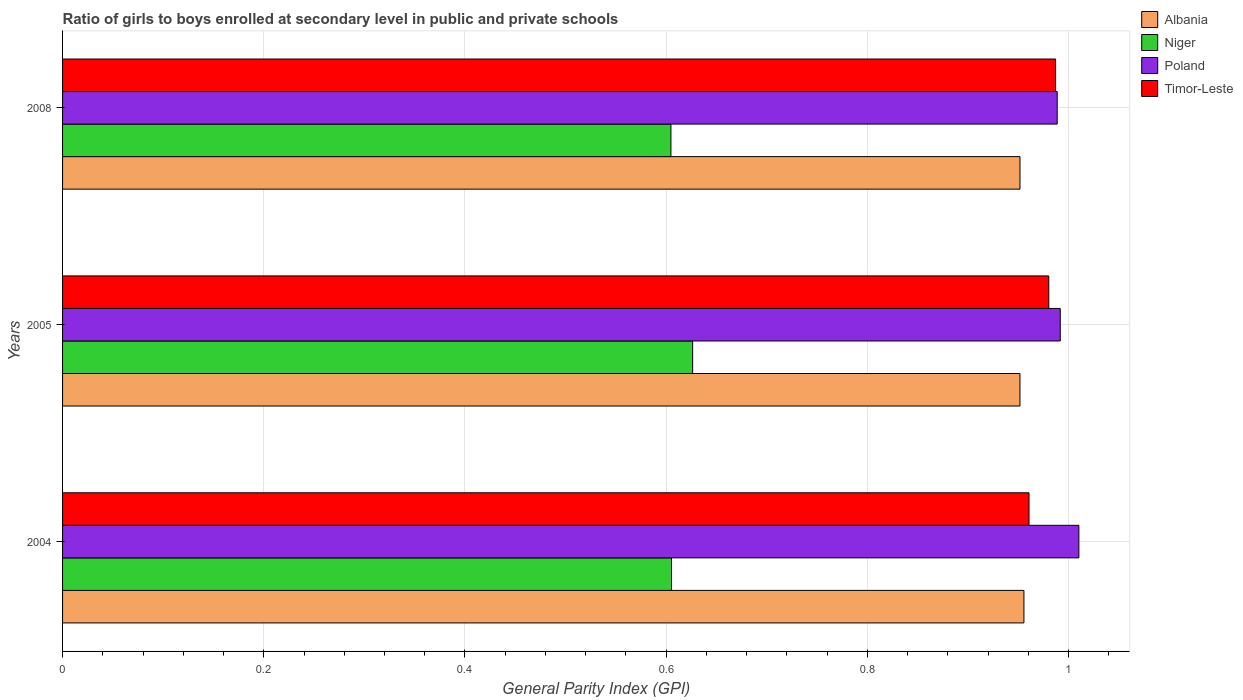How many different coloured bars are there?
Make the answer very short. 4. How many bars are there on the 1st tick from the top?
Give a very brief answer. 4. What is the label of the 2nd group of bars from the top?
Provide a short and direct response. 2005. In how many cases, is the number of bars for a given year not equal to the number of legend labels?
Provide a short and direct response. 0. What is the general parity index in Timor-Leste in 2008?
Keep it short and to the point. 0.99. Across all years, what is the maximum general parity index in Poland?
Your answer should be compact. 1.01. Across all years, what is the minimum general parity index in Poland?
Your response must be concise. 0.99. What is the total general parity index in Poland in the graph?
Make the answer very short. 2.99. What is the difference between the general parity index in Poland in 2005 and that in 2008?
Keep it short and to the point. 0. What is the difference between the general parity index in Niger in 2004 and the general parity index in Poland in 2005?
Provide a short and direct response. -0.39. What is the average general parity index in Timor-Leste per year?
Your answer should be compact. 0.98. In the year 2005, what is the difference between the general parity index in Timor-Leste and general parity index in Niger?
Your answer should be very brief. 0.35. In how many years, is the general parity index in Timor-Leste greater than 0.52 ?
Offer a terse response. 3. What is the ratio of the general parity index in Niger in 2005 to that in 2008?
Provide a short and direct response. 1.04. What is the difference between the highest and the second highest general parity index in Albania?
Provide a short and direct response. 0. What is the difference between the highest and the lowest general parity index in Albania?
Ensure brevity in your answer.  0. Is it the case that in every year, the sum of the general parity index in Timor-Leste and general parity index in Albania is greater than the sum of general parity index in Poland and general parity index in Niger?
Keep it short and to the point. Yes. What does the 3rd bar from the top in 2005 represents?
Provide a short and direct response. Niger. What does the 4th bar from the bottom in 2008 represents?
Provide a short and direct response. Timor-Leste. Are all the bars in the graph horizontal?
Offer a terse response. Yes. How many years are there in the graph?
Keep it short and to the point. 3. What is the difference between two consecutive major ticks on the X-axis?
Provide a succinct answer. 0.2. Are the values on the major ticks of X-axis written in scientific E-notation?
Keep it short and to the point. No. Does the graph contain any zero values?
Your response must be concise. No. How many legend labels are there?
Offer a terse response. 4. How are the legend labels stacked?
Your answer should be very brief. Vertical. What is the title of the graph?
Your response must be concise. Ratio of girls to boys enrolled at secondary level in public and private schools. What is the label or title of the X-axis?
Provide a short and direct response. General Parity Index (GPI). What is the label or title of the Y-axis?
Provide a succinct answer. Years. What is the General Parity Index (GPI) in Albania in 2004?
Your response must be concise. 0.96. What is the General Parity Index (GPI) of Niger in 2004?
Keep it short and to the point. 0.61. What is the General Parity Index (GPI) of Poland in 2004?
Your response must be concise. 1.01. What is the General Parity Index (GPI) in Timor-Leste in 2004?
Ensure brevity in your answer.  0.96. What is the General Parity Index (GPI) in Albania in 2005?
Ensure brevity in your answer.  0.95. What is the General Parity Index (GPI) of Niger in 2005?
Keep it short and to the point. 0.63. What is the General Parity Index (GPI) of Poland in 2005?
Ensure brevity in your answer.  0.99. What is the General Parity Index (GPI) of Timor-Leste in 2005?
Your answer should be compact. 0.98. What is the General Parity Index (GPI) of Albania in 2008?
Provide a succinct answer. 0.95. What is the General Parity Index (GPI) of Niger in 2008?
Your answer should be compact. 0.6. What is the General Parity Index (GPI) of Poland in 2008?
Provide a short and direct response. 0.99. What is the General Parity Index (GPI) of Timor-Leste in 2008?
Your answer should be compact. 0.99. Across all years, what is the maximum General Parity Index (GPI) of Albania?
Your answer should be very brief. 0.96. Across all years, what is the maximum General Parity Index (GPI) in Niger?
Your response must be concise. 0.63. Across all years, what is the maximum General Parity Index (GPI) in Poland?
Make the answer very short. 1.01. Across all years, what is the maximum General Parity Index (GPI) in Timor-Leste?
Ensure brevity in your answer.  0.99. Across all years, what is the minimum General Parity Index (GPI) of Albania?
Your answer should be compact. 0.95. Across all years, what is the minimum General Parity Index (GPI) of Niger?
Your answer should be very brief. 0.6. Across all years, what is the minimum General Parity Index (GPI) in Poland?
Your answer should be very brief. 0.99. Across all years, what is the minimum General Parity Index (GPI) in Timor-Leste?
Give a very brief answer. 0.96. What is the total General Parity Index (GPI) in Albania in the graph?
Your answer should be compact. 2.86. What is the total General Parity Index (GPI) in Niger in the graph?
Provide a short and direct response. 1.84. What is the total General Parity Index (GPI) of Poland in the graph?
Ensure brevity in your answer.  2.99. What is the total General Parity Index (GPI) of Timor-Leste in the graph?
Give a very brief answer. 2.93. What is the difference between the General Parity Index (GPI) in Albania in 2004 and that in 2005?
Make the answer very short. 0. What is the difference between the General Parity Index (GPI) of Niger in 2004 and that in 2005?
Your response must be concise. -0.02. What is the difference between the General Parity Index (GPI) in Poland in 2004 and that in 2005?
Keep it short and to the point. 0.02. What is the difference between the General Parity Index (GPI) in Timor-Leste in 2004 and that in 2005?
Your answer should be compact. -0.02. What is the difference between the General Parity Index (GPI) in Albania in 2004 and that in 2008?
Your response must be concise. 0. What is the difference between the General Parity Index (GPI) of Niger in 2004 and that in 2008?
Offer a terse response. 0. What is the difference between the General Parity Index (GPI) of Poland in 2004 and that in 2008?
Your answer should be very brief. 0.02. What is the difference between the General Parity Index (GPI) in Timor-Leste in 2004 and that in 2008?
Provide a short and direct response. -0.03. What is the difference between the General Parity Index (GPI) of Niger in 2005 and that in 2008?
Your answer should be compact. 0.02. What is the difference between the General Parity Index (GPI) of Poland in 2005 and that in 2008?
Your response must be concise. 0. What is the difference between the General Parity Index (GPI) of Timor-Leste in 2005 and that in 2008?
Your response must be concise. -0.01. What is the difference between the General Parity Index (GPI) of Albania in 2004 and the General Parity Index (GPI) of Niger in 2005?
Provide a succinct answer. 0.33. What is the difference between the General Parity Index (GPI) in Albania in 2004 and the General Parity Index (GPI) in Poland in 2005?
Provide a short and direct response. -0.04. What is the difference between the General Parity Index (GPI) of Albania in 2004 and the General Parity Index (GPI) of Timor-Leste in 2005?
Offer a terse response. -0.02. What is the difference between the General Parity Index (GPI) of Niger in 2004 and the General Parity Index (GPI) of Poland in 2005?
Provide a short and direct response. -0.39. What is the difference between the General Parity Index (GPI) in Niger in 2004 and the General Parity Index (GPI) in Timor-Leste in 2005?
Provide a succinct answer. -0.38. What is the difference between the General Parity Index (GPI) of Poland in 2004 and the General Parity Index (GPI) of Timor-Leste in 2005?
Make the answer very short. 0.03. What is the difference between the General Parity Index (GPI) of Albania in 2004 and the General Parity Index (GPI) of Niger in 2008?
Make the answer very short. 0.35. What is the difference between the General Parity Index (GPI) of Albania in 2004 and the General Parity Index (GPI) of Poland in 2008?
Provide a short and direct response. -0.03. What is the difference between the General Parity Index (GPI) in Albania in 2004 and the General Parity Index (GPI) in Timor-Leste in 2008?
Make the answer very short. -0.03. What is the difference between the General Parity Index (GPI) in Niger in 2004 and the General Parity Index (GPI) in Poland in 2008?
Ensure brevity in your answer.  -0.38. What is the difference between the General Parity Index (GPI) in Niger in 2004 and the General Parity Index (GPI) in Timor-Leste in 2008?
Give a very brief answer. -0.38. What is the difference between the General Parity Index (GPI) of Poland in 2004 and the General Parity Index (GPI) of Timor-Leste in 2008?
Ensure brevity in your answer.  0.02. What is the difference between the General Parity Index (GPI) of Albania in 2005 and the General Parity Index (GPI) of Niger in 2008?
Your answer should be very brief. 0.35. What is the difference between the General Parity Index (GPI) of Albania in 2005 and the General Parity Index (GPI) of Poland in 2008?
Your response must be concise. -0.04. What is the difference between the General Parity Index (GPI) in Albania in 2005 and the General Parity Index (GPI) in Timor-Leste in 2008?
Ensure brevity in your answer.  -0.04. What is the difference between the General Parity Index (GPI) in Niger in 2005 and the General Parity Index (GPI) in Poland in 2008?
Keep it short and to the point. -0.36. What is the difference between the General Parity Index (GPI) of Niger in 2005 and the General Parity Index (GPI) of Timor-Leste in 2008?
Offer a very short reply. -0.36. What is the difference between the General Parity Index (GPI) in Poland in 2005 and the General Parity Index (GPI) in Timor-Leste in 2008?
Your response must be concise. 0. What is the average General Parity Index (GPI) in Albania per year?
Ensure brevity in your answer.  0.95. What is the average General Parity Index (GPI) of Niger per year?
Offer a terse response. 0.61. What is the average General Parity Index (GPI) of Timor-Leste per year?
Offer a very short reply. 0.98. In the year 2004, what is the difference between the General Parity Index (GPI) in Albania and General Parity Index (GPI) in Niger?
Your answer should be compact. 0.35. In the year 2004, what is the difference between the General Parity Index (GPI) of Albania and General Parity Index (GPI) of Poland?
Keep it short and to the point. -0.05. In the year 2004, what is the difference between the General Parity Index (GPI) of Albania and General Parity Index (GPI) of Timor-Leste?
Your answer should be compact. -0.01. In the year 2004, what is the difference between the General Parity Index (GPI) of Niger and General Parity Index (GPI) of Poland?
Provide a succinct answer. -0.4. In the year 2004, what is the difference between the General Parity Index (GPI) of Niger and General Parity Index (GPI) of Timor-Leste?
Keep it short and to the point. -0.36. In the year 2004, what is the difference between the General Parity Index (GPI) of Poland and General Parity Index (GPI) of Timor-Leste?
Provide a succinct answer. 0.05. In the year 2005, what is the difference between the General Parity Index (GPI) of Albania and General Parity Index (GPI) of Niger?
Provide a short and direct response. 0.33. In the year 2005, what is the difference between the General Parity Index (GPI) of Albania and General Parity Index (GPI) of Poland?
Keep it short and to the point. -0.04. In the year 2005, what is the difference between the General Parity Index (GPI) of Albania and General Parity Index (GPI) of Timor-Leste?
Ensure brevity in your answer.  -0.03. In the year 2005, what is the difference between the General Parity Index (GPI) in Niger and General Parity Index (GPI) in Poland?
Provide a succinct answer. -0.37. In the year 2005, what is the difference between the General Parity Index (GPI) in Niger and General Parity Index (GPI) in Timor-Leste?
Offer a very short reply. -0.35. In the year 2005, what is the difference between the General Parity Index (GPI) in Poland and General Parity Index (GPI) in Timor-Leste?
Provide a succinct answer. 0.01. In the year 2008, what is the difference between the General Parity Index (GPI) in Albania and General Parity Index (GPI) in Niger?
Ensure brevity in your answer.  0.35. In the year 2008, what is the difference between the General Parity Index (GPI) in Albania and General Parity Index (GPI) in Poland?
Your response must be concise. -0.04. In the year 2008, what is the difference between the General Parity Index (GPI) of Albania and General Parity Index (GPI) of Timor-Leste?
Provide a short and direct response. -0.04. In the year 2008, what is the difference between the General Parity Index (GPI) in Niger and General Parity Index (GPI) in Poland?
Provide a succinct answer. -0.38. In the year 2008, what is the difference between the General Parity Index (GPI) in Niger and General Parity Index (GPI) in Timor-Leste?
Give a very brief answer. -0.38. In the year 2008, what is the difference between the General Parity Index (GPI) in Poland and General Parity Index (GPI) in Timor-Leste?
Ensure brevity in your answer.  0. What is the ratio of the General Parity Index (GPI) in Albania in 2004 to that in 2005?
Ensure brevity in your answer.  1. What is the ratio of the General Parity Index (GPI) of Niger in 2004 to that in 2005?
Provide a short and direct response. 0.97. What is the ratio of the General Parity Index (GPI) in Poland in 2004 to that in 2005?
Your answer should be compact. 1.02. What is the ratio of the General Parity Index (GPI) of Timor-Leste in 2004 to that in 2005?
Your answer should be very brief. 0.98. What is the ratio of the General Parity Index (GPI) in Albania in 2004 to that in 2008?
Your answer should be compact. 1. What is the ratio of the General Parity Index (GPI) of Niger in 2004 to that in 2008?
Your answer should be compact. 1. What is the ratio of the General Parity Index (GPI) of Poland in 2004 to that in 2008?
Your response must be concise. 1.02. What is the ratio of the General Parity Index (GPI) of Timor-Leste in 2004 to that in 2008?
Provide a short and direct response. 0.97. What is the ratio of the General Parity Index (GPI) of Albania in 2005 to that in 2008?
Provide a short and direct response. 1. What is the ratio of the General Parity Index (GPI) of Niger in 2005 to that in 2008?
Ensure brevity in your answer.  1.04. What is the ratio of the General Parity Index (GPI) of Poland in 2005 to that in 2008?
Ensure brevity in your answer.  1. What is the difference between the highest and the second highest General Parity Index (GPI) in Albania?
Offer a very short reply. 0. What is the difference between the highest and the second highest General Parity Index (GPI) in Niger?
Make the answer very short. 0.02. What is the difference between the highest and the second highest General Parity Index (GPI) in Poland?
Offer a terse response. 0.02. What is the difference between the highest and the second highest General Parity Index (GPI) in Timor-Leste?
Offer a terse response. 0.01. What is the difference between the highest and the lowest General Parity Index (GPI) of Albania?
Make the answer very short. 0. What is the difference between the highest and the lowest General Parity Index (GPI) of Niger?
Your answer should be very brief. 0.02. What is the difference between the highest and the lowest General Parity Index (GPI) in Poland?
Provide a short and direct response. 0.02. What is the difference between the highest and the lowest General Parity Index (GPI) in Timor-Leste?
Provide a succinct answer. 0.03. 